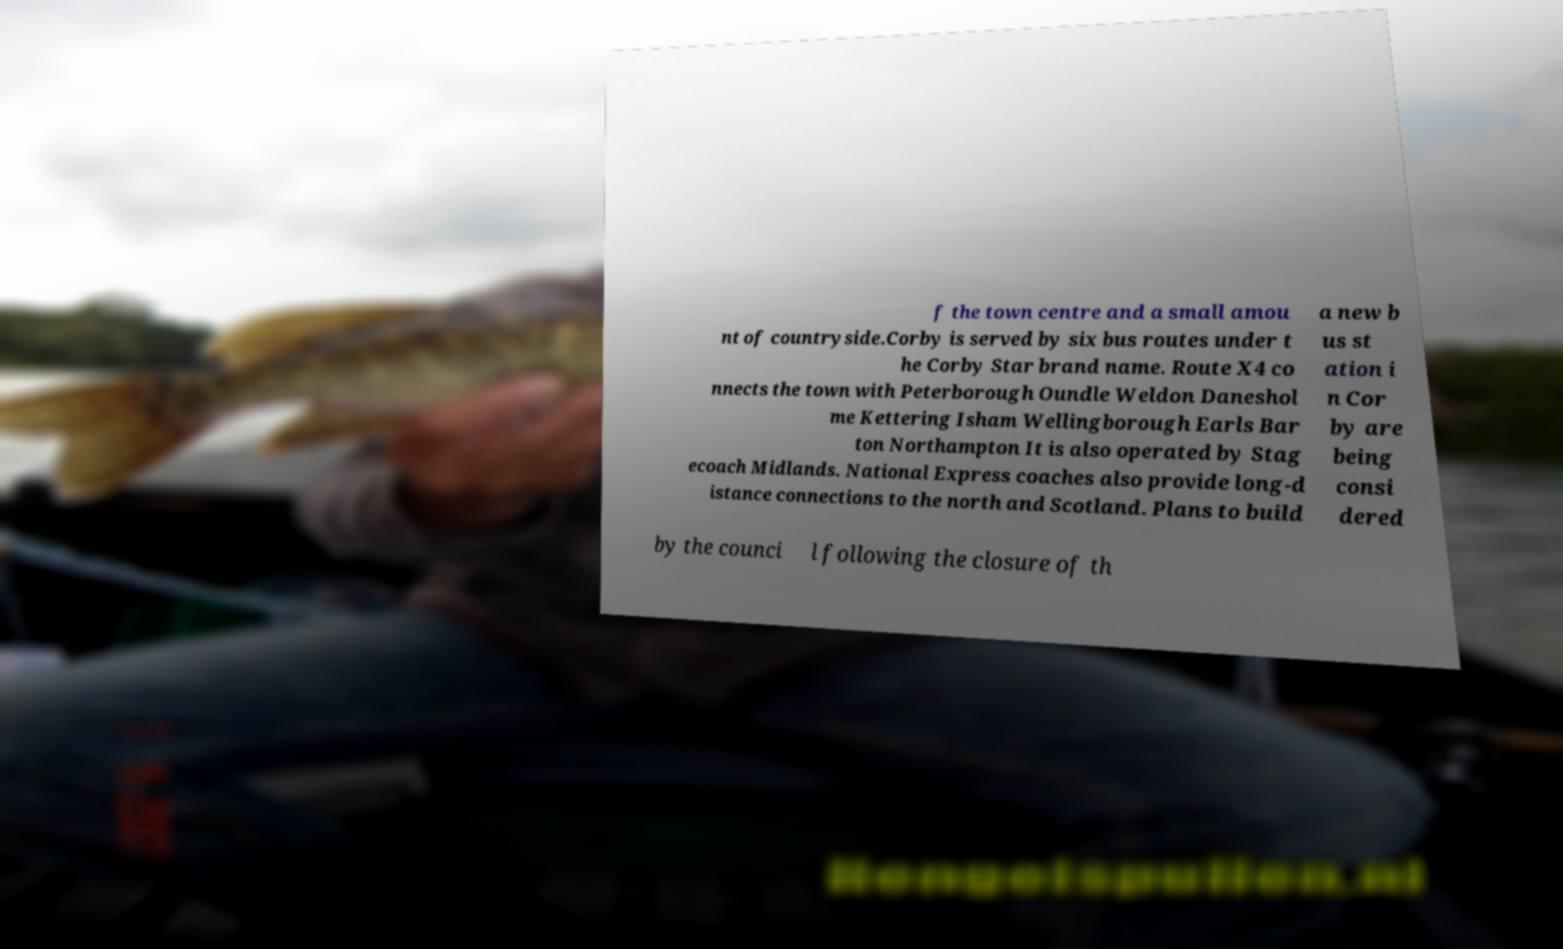Could you extract and type out the text from this image? f the town centre and a small amou nt of countryside.Corby is served by six bus routes under t he Corby Star brand name. Route X4 co nnects the town with Peterborough Oundle Weldon Daneshol me Kettering Isham Wellingborough Earls Bar ton Northampton It is also operated by Stag ecoach Midlands. National Express coaches also provide long-d istance connections to the north and Scotland. Plans to build a new b us st ation i n Cor by are being consi dered by the counci l following the closure of th 